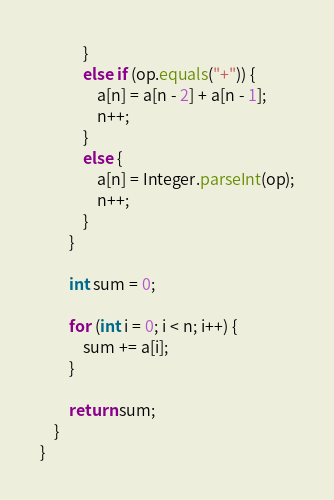Convert code to text. <code><loc_0><loc_0><loc_500><loc_500><_Java_>            }
            else if (op.equals("+")) {
                a[n] = a[n - 2] + a[n - 1];
                n++;
            }
            else {
                a[n] = Integer.parseInt(op);
                n++;
            }
        }
        
        int sum = 0;
        
        for (int i = 0; i < n; i++) {
            sum += a[i];
        }
        
        return sum;
    }
}
</code> 